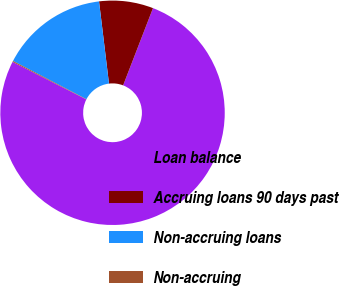Convert chart to OTSL. <chart><loc_0><loc_0><loc_500><loc_500><pie_chart><fcel>Loan balance<fcel>Accruing loans 90 days past<fcel>Non-accruing loans<fcel>Non-accruing<nl><fcel>76.62%<fcel>7.79%<fcel>15.44%<fcel>0.14%<nl></chart> 